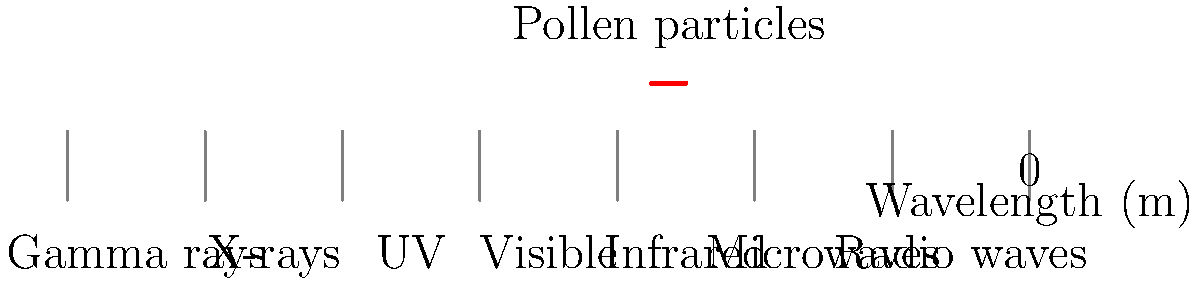Based on the electromagnetic spectrum diagram, which region is most likely associated with the size of pollen particles that trigger hay fever symptoms? How does this relate to the visible light spectrum? To answer this question, let's follow these steps:

1. Observe the diagram: The electromagnetic spectrum is shown with wavelengths ranging from $10^{-14}$ m to $1$ m.

2. Identify pollen particle size: Pollen particles typically range from about $10$ to $100$ micrometers in diameter. In scientific notation, this is $10^{-5}$ to $10^{-4}$ m.

3. Locate on spectrum: The red line indicating pollen particles is shown around the boundary between infrared and microwave regions, which corresponds to wavelengths of about $10^{-4}$ to $10^{-3}$ m.

4. Compare to visible light: The visible light spectrum ranges from about $380$ nm to $740$ nm, or $3.8 \times 10^{-7}$ m to $7.4 \times 10^{-7}$ m.

5. Relate size to wavelength: Pollen particles are larger than the wavelengths of visible light. This explains why we can see pollen with the naked eye or with simple magnification.

6. Conclude: The region most associated with pollen particle size is the infrared to microwave boundary, which has longer wavelengths than visible light.
Answer: Infrared-microwave boundary; larger than visible light wavelengths 